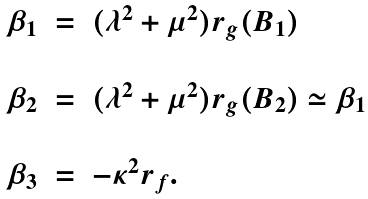Convert formula to latex. <formula><loc_0><loc_0><loc_500><loc_500>\begin{array} { l l l } \beta _ { 1 } & = & ( \lambda ^ { 2 } + \mu ^ { 2 } ) r _ { g } ( B _ { 1 } ) \\ & & \\ \beta _ { 2 } & = & ( \lambda ^ { 2 } + \mu ^ { 2 } ) r _ { g } ( B _ { 2 } ) \simeq \beta _ { 1 } \\ & & \\ \beta _ { 3 } & = & - \kappa ^ { 2 } r _ { f } . \end{array}</formula> 